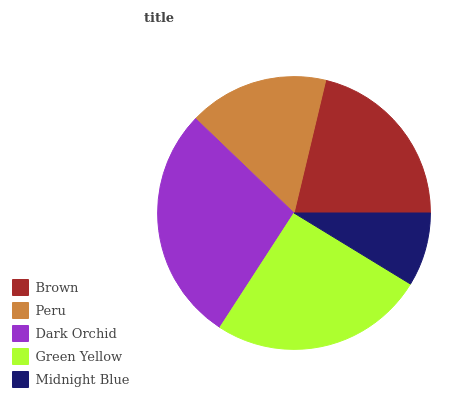Is Midnight Blue the minimum?
Answer yes or no. Yes. Is Dark Orchid the maximum?
Answer yes or no. Yes. Is Peru the minimum?
Answer yes or no. No. Is Peru the maximum?
Answer yes or no. No. Is Brown greater than Peru?
Answer yes or no. Yes. Is Peru less than Brown?
Answer yes or no. Yes. Is Peru greater than Brown?
Answer yes or no. No. Is Brown less than Peru?
Answer yes or no. No. Is Brown the high median?
Answer yes or no. Yes. Is Brown the low median?
Answer yes or no. Yes. Is Peru the high median?
Answer yes or no. No. Is Peru the low median?
Answer yes or no. No. 